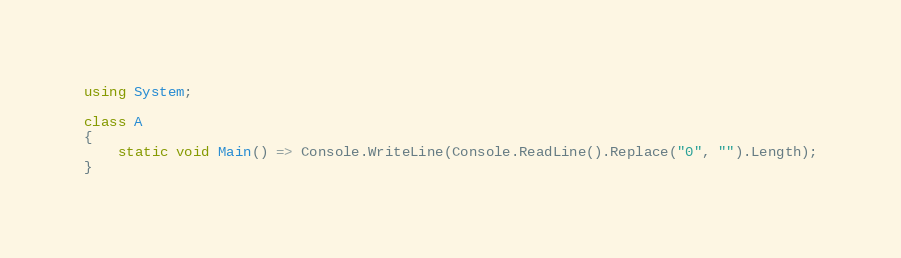<code> <loc_0><loc_0><loc_500><loc_500><_C#_>using System;

class A
{
	static void Main() => Console.WriteLine(Console.ReadLine().Replace("0", "").Length);
}
</code> 